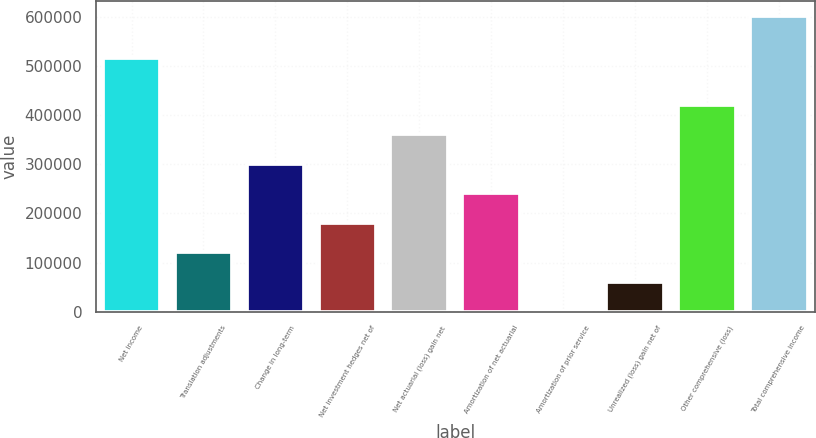<chart> <loc_0><loc_0><loc_500><loc_500><bar_chart><fcel>Net income<fcel>Translation adjustments<fcel>Change in long-term<fcel>Net investment hedges net of<fcel>Net actuarial (loss) gain net<fcel>Amortization of net actuarial<fcel>Amortization of prior service<fcel>Unrealized (loss) gain net of<fcel>Other comprehensive (loss)<fcel>Total comprehensive income<nl><fcel>516999<fcel>120757<fcel>301632<fcel>181049<fcel>361924<fcel>241340<fcel>174<fcel>60465.6<fcel>422215<fcel>603090<nl></chart> 